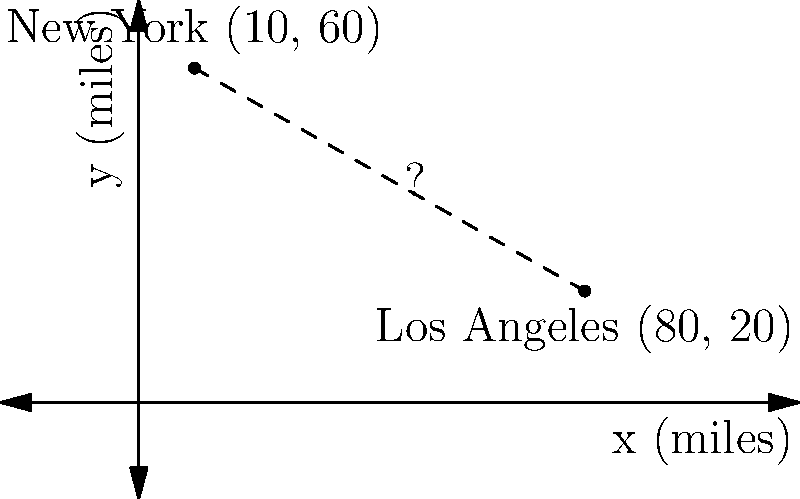As part of your initiative to support educational opportunities across the country, you're planning to establish a scholarship program connecting students from New York to internships in Los Angeles. To budget for travel expenses, you need to calculate the direct distance between these two cities. Given that New York is located at coordinates (10, 60) and Los Angeles at (80, 20) on a map where each unit represents 10 miles, what is the approximate distance between these cities? Use the distance formula: $$d = \sqrt{(x_2-x_1)^2 + (y_2-y_1)^2}$$ Let's approach this step-by-step:

1) We have two points:
   New York: $(x_1, y_1) = (10, 60)$
   Los Angeles: $(x_2, y_2) = (80, 20)$

2) Let's substitute these into the distance formula:
   $$d = \sqrt{(x_2-x_1)^2 + (y_2-y_1)^2}$$
   $$d = \sqrt{(80-10)^2 + (20-60)^2}$$

3) Simplify inside the parentheses:
   $$d = \sqrt{(70)^2 + (-40)^2}$$

4) Calculate the squares:
   $$d = \sqrt{4900 + 1600}$$

5) Add under the square root:
   $$d = \sqrt{6500}$$

6) Take the square root:
   $$d \approx 80.62$$

7) Remember that each unit represents 10 miles, so multiply by 10:
   $$d \approx 80.62 \times 10 = 806.2 \text{ miles}$$

Therefore, the approximate distance between New York and Los Angeles is about 806 miles.
Answer: 806 miles 